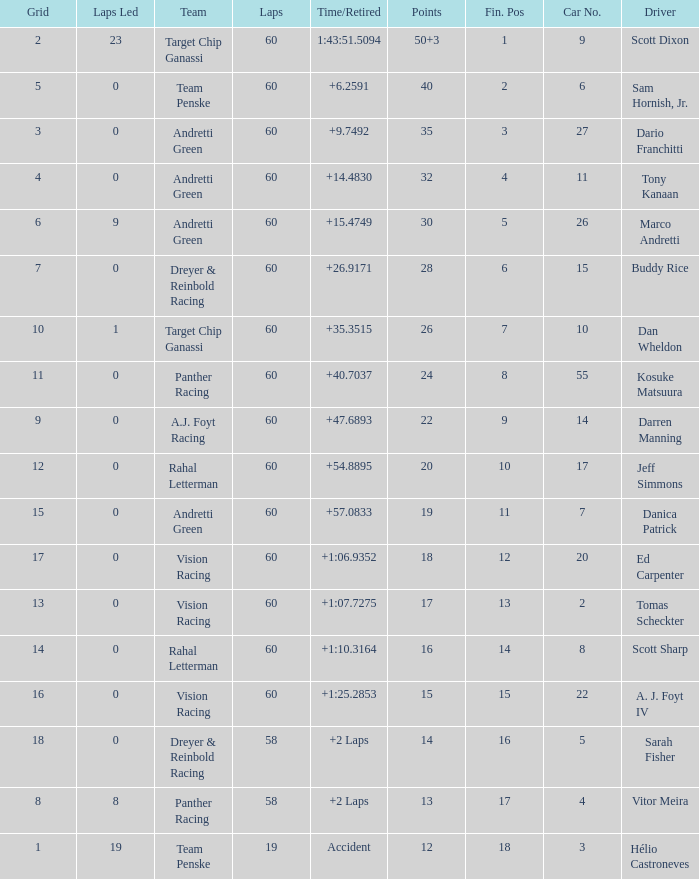Name the drive for points being 13 Vitor Meira. Parse the full table. {'header': ['Grid', 'Laps Led', 'Team', 'Laps', 'Time/Retired', 'Points', 'Fin. Pos', 'Car No.', 'Driver'], 'rows': [['2', '23', 'Target Chip Ganassi', '60', '1:43:51.5094', '50+3', '1', '9', 'Scott Dixon'], ['5', '0', 'Team Penske', '60', '+6.2591', '40', '2', '6', 'Sam Hornish, Jr.'], ['3', '0', 'Andretti Green', '60', '+9.7492', '35', '3', '27', 'Dario Franchitti'], ['4', '0', 'Andretti Green', '60', '+14.4830', '32', '4', '11', 'Tony Kanaan'], ['6', '9', 'Andretti Green', '60', '+15.4749', '30', '5', '26', 'Marco Andretti'], ['7', '0', 'Dreyer & Reinbold Racing', '60', '+26.9171', '28', '6', '15', 'Buddy Rice'], ['10', '1', 'Target Chip Ganassi', '60', '+35.3515', '26', '7', '10', 'Dan Wheldon'], ['11', '0', 'Panther Racing', '60', '+40.7037', '24', '8', '55', 'Kosuke Matsuura'], ['9', '0', 'A.J. Foyt Racing', '60', '+47.6893', '22', '9', '14', 'Darren Manning'], ['12', '0', 'Rahal Letterman', '60', '+54.8895', '20', '10', '17', 'Jeff Simmons'], ['15', '0', 'Andretti Green', '60', '+57.0833', '19', '11', '7', 'Danica Patrick'], ['17', '0', 'Vision Racing', '60', '+1:06.9352', '18', '12', '20', 'Ed Carpenter'], ['13', '0', 'Vision Racing', '60', '+1:07.7275', '17', '13', '2', 'Tomas Scheckter'], ['14', '0', 'Rahal Letterman', '60', '+1:10.3164', '16', '14', '8', 'Scott Sharp'], ['16', '0', 'Vision Racing', '60', '+1:25.2853', '15', '15', '22', 'A. J. Foyt IV'], ['18', '0', 'Dreyer & Reinbold Racing', '58', '+2 Laps', '14', '16', '5', 'Sarah Fisher'], ['8', '8', 'Panther Racing', '58', '+2 Laps', '13', '17', '4', 'Vitor Meira'], ['1', '19', 'Team Penske', '19', 'Accident', '12', '18', '3', 'Hélio Castroneves']]} 